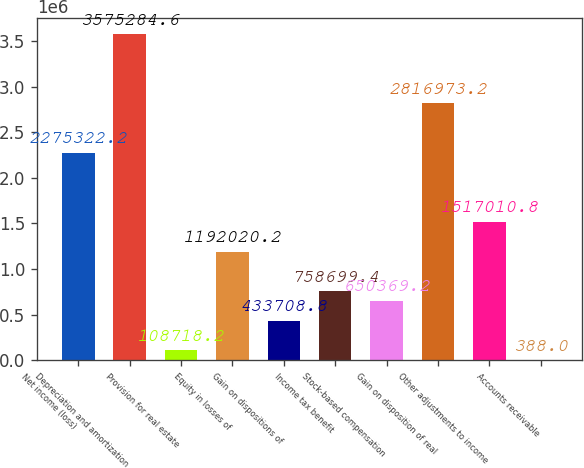<chart> <loc_0><loc_0><loc_500><loc_500><bar_chart><fcel>Net income (loss)<fcel>Depreciation and amortization<fcel>Provision for real estate<fcel>Equity in losses of<fcel>Gain on dispositions of<fcel>Income tax benefit<fcel>Stock-based compensation<fcel>Gain on disposition of real<fcel>Other adjustments to income<fcel>Accounts receivable<nl><fcel>2.27532e+06<fcel>3.57528e+06<fcel>108718<fcel>1.19202e+06<fcel>433709<fcel>758699<fcel>650369<fcel>2.81697e+06<fcel>1.51701e+06<fcel>388<nl></chart> 